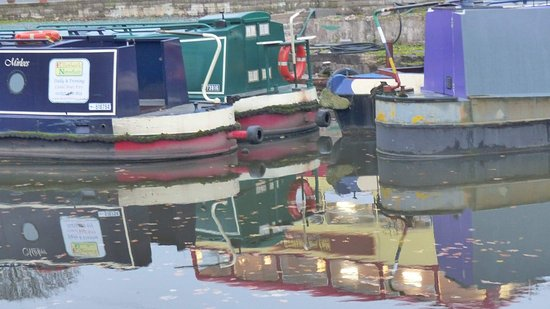What can we infer about the setting from the image? The moored boats and visible narrow berths suggest a tranquil canal or marina setting, likely a spot accustomed to leisure boating or residential boats. Are there any elements that indicate the time of day or season? There's a softness to the light and a lack of harsh shadows which could suggest early morning or late afternoon. The absence of foliage on the trees in the background might imply it's either late fall or winter. 